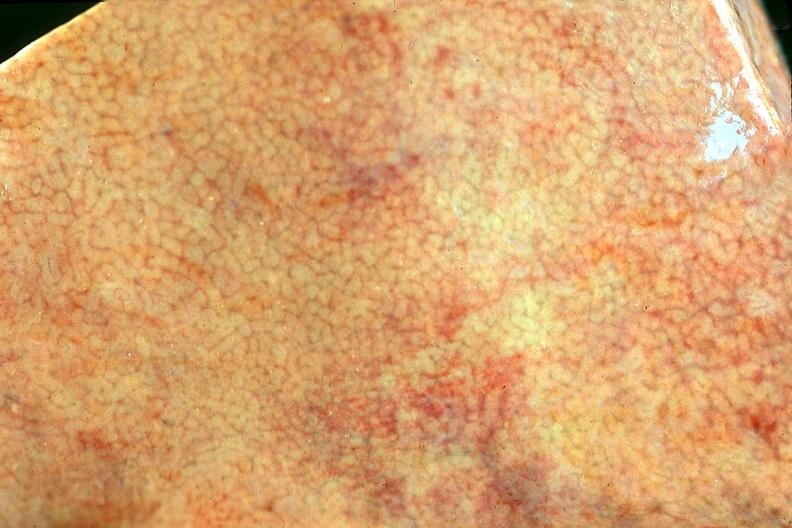s malignant adenoma present?
Answer the question using a single word or phrase. No 